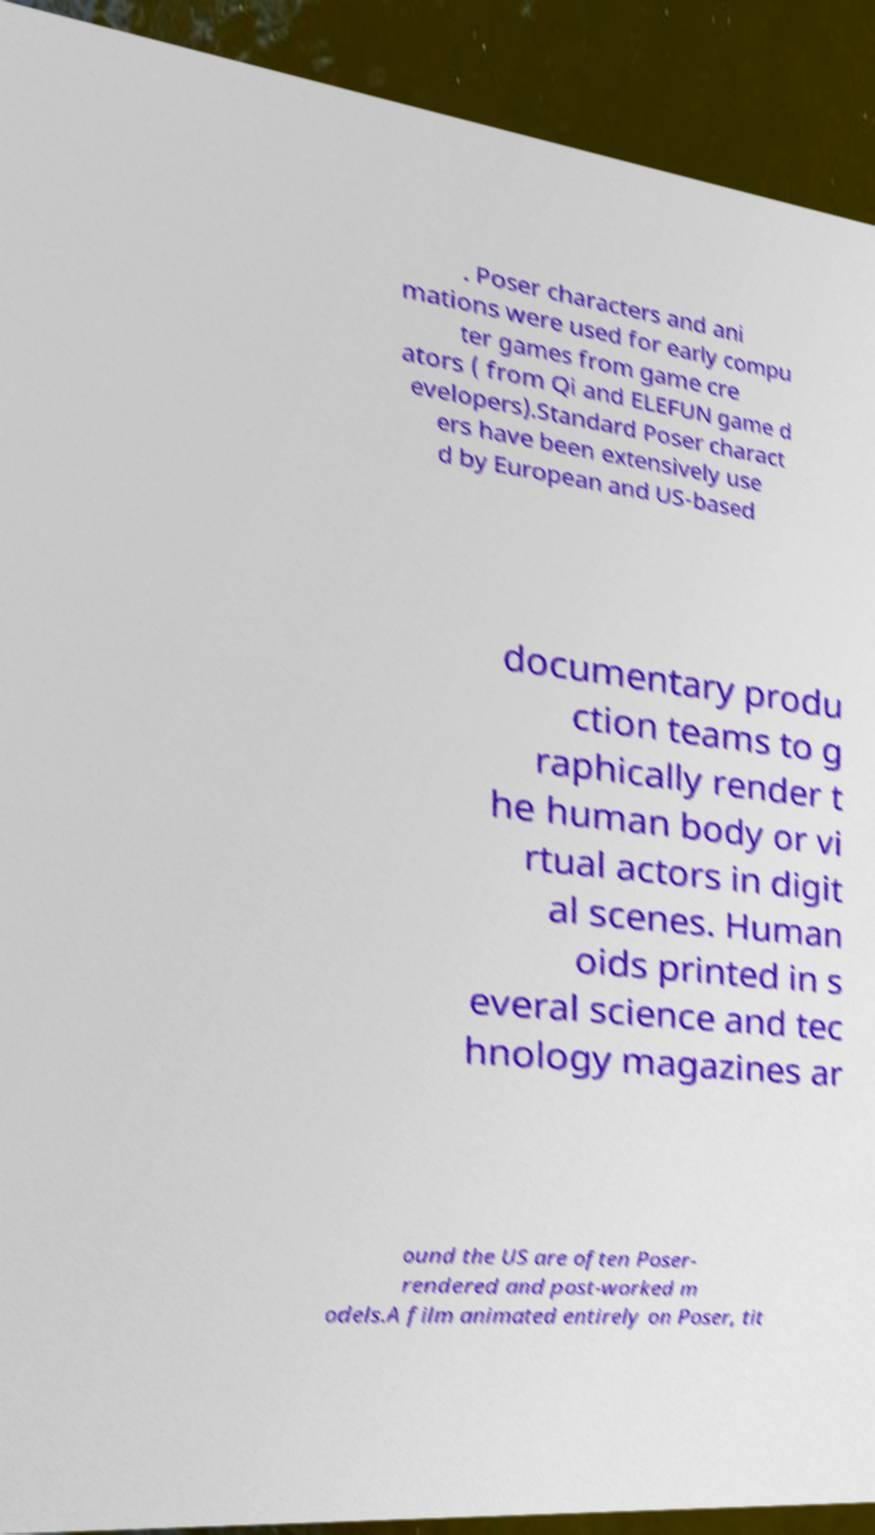Can you accurately transcribe the text from the provided image for me? . Poser characters and ani mations were used for early compu ter games from game cre ators ( from Qi and ELEFUN game d evelopers).Standard Poser charact ers have been extensively use d by European and US-based documentary produ ction teams to g raphically render t he human body or vi rtual actors in digit al scenes. Human oids printed in s everal science and tec hnology magazines ar ound the US are often Poser- rendered and post-worked m odels.A film animated entirely on Poser, tit 